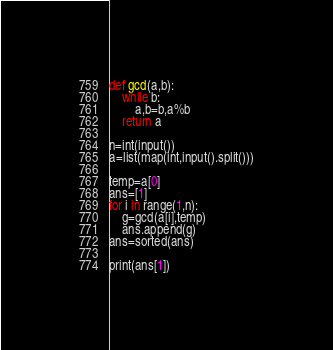<code> <loc_0><loc_0><loc_500><loc_500><_Python_>def gcd(a,b):
    while b:
        a,b=b,a%b
    return a

n=int(input())
a=list(map(int,input().split()))

temp=a[0]
ans=[1]
for i in range(1,n):
    g=gcd(a[i],temp)
    ans.append(g)
ans=sorted(ans)

print(ans[1])
</code> 